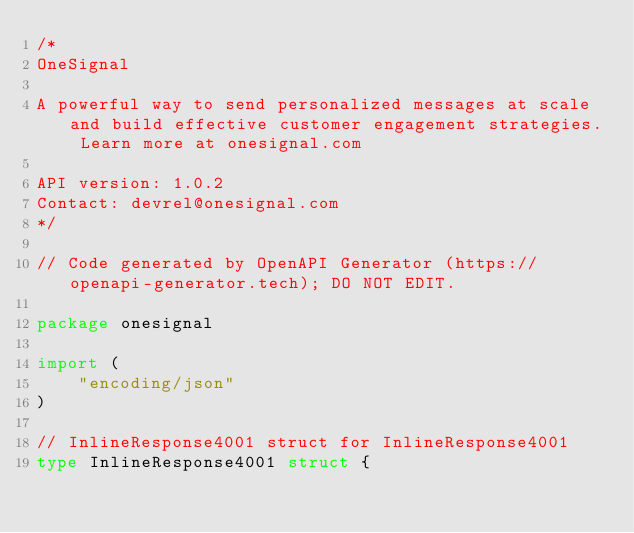Convert code to text. <code><loc_0><loc_0><loc_500><loc_500><_Go_>/*
OneSignal

A powerful way to send personalized messages at scale and build effective customer engagement strategies. Learn more at onesignal.com

API version: 1.0.2
Contact: devrel@onesignal.com
*/

// Code generated by OpenAPI Generator (https://openapi-generator.tech); DO NOT EDIT.

package onesignal

import (
	"encoding/json"
)

// InlineResponse4001 struct for InlineResponse4001
type InlineResponse4001 struct {</code> 